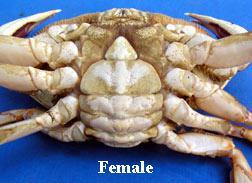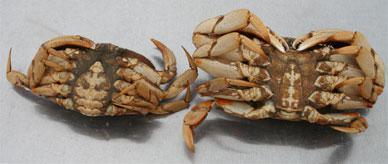The first image is the image on the left, the second image is the image on the right. Assess this claim about the two images: "there are three crabs in the image pair". Correct or not? Answer yes or no. Yes. The first image is the image on the left, the second image is the image on the right. For the images displayed, is the sentence "The right image includes at least one hand grasping a crab with its shell removed, while the left image shows a view of a crab with no hands present." factually correct? Answer yes or no. No. 